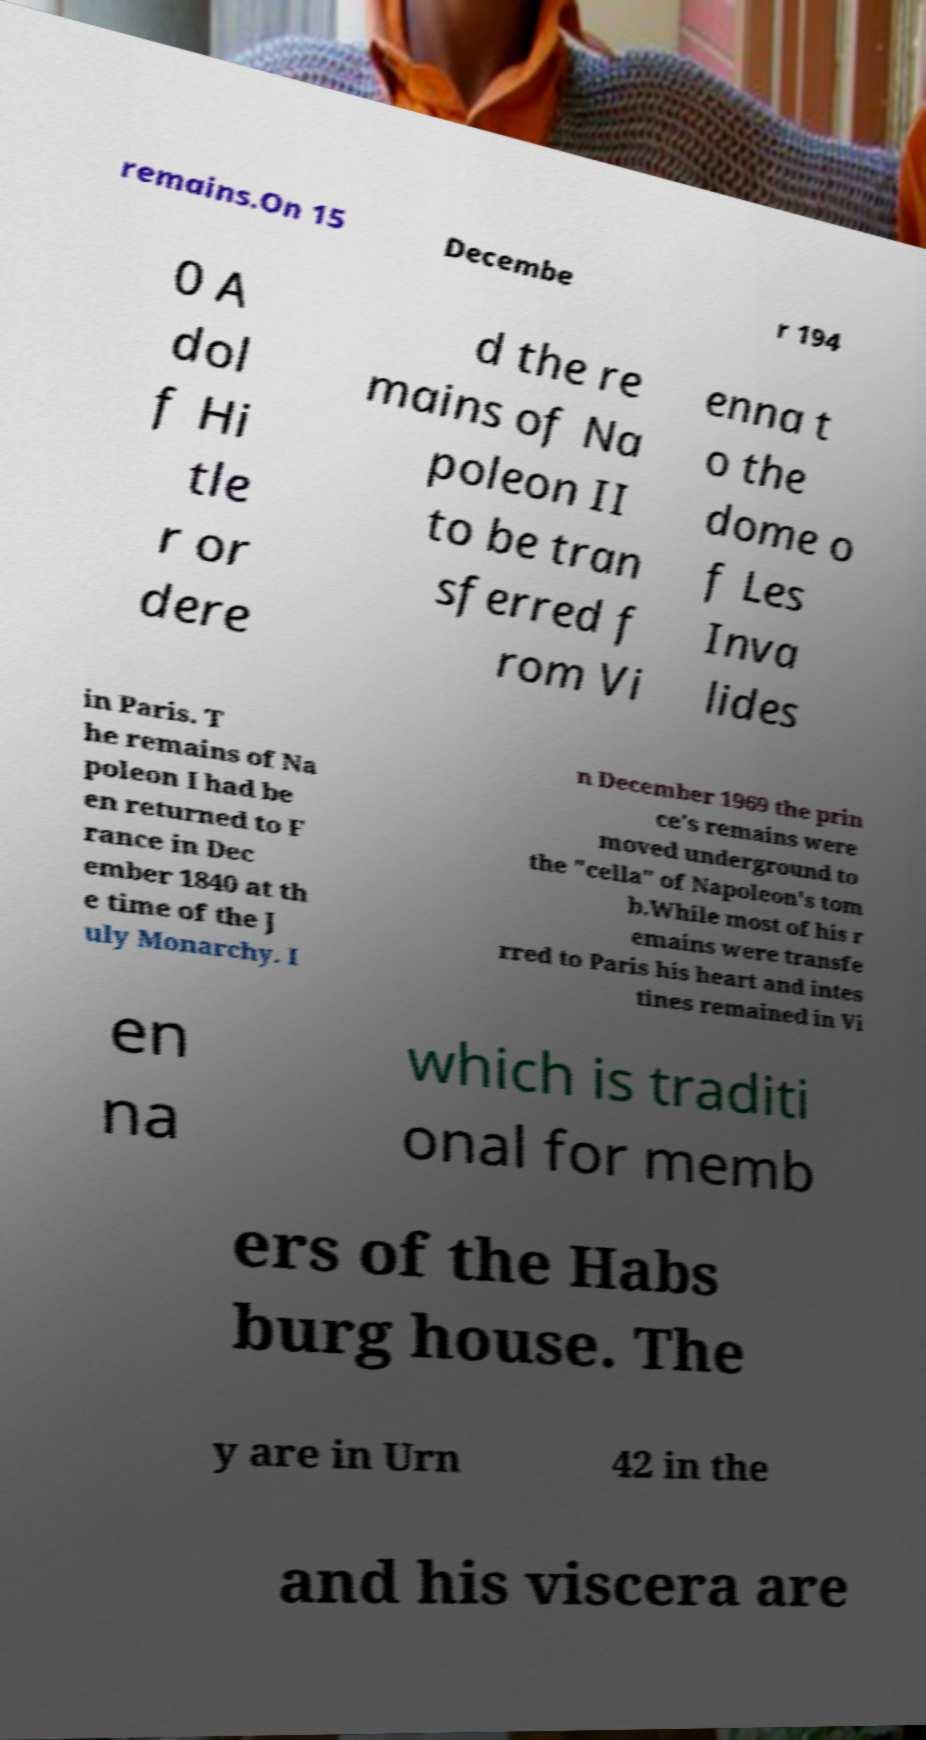Could you extract and type out the text from this image? remains.On 15 Decembe r 194 0 A dol f Hi tle r or dere d the re mains of Na poleon II to be tran sferred f rom Vi enna t o the dome o f Les Inva lides in Paris. T he remains of Na poleon I had be en returned to F rance in Dec ember 1840 at th e time of the J uly Monarchy. I n December 1969 the prin ce's remains were moved underground to the "cella" of Napoleon's tom b.While most of his r emains were transfe rred to Paris his heart and intes tines remained in Vi en na which is traditi onal for memb ers of the Habs burg house. The y are in Urn 42 in the and his viscera are 